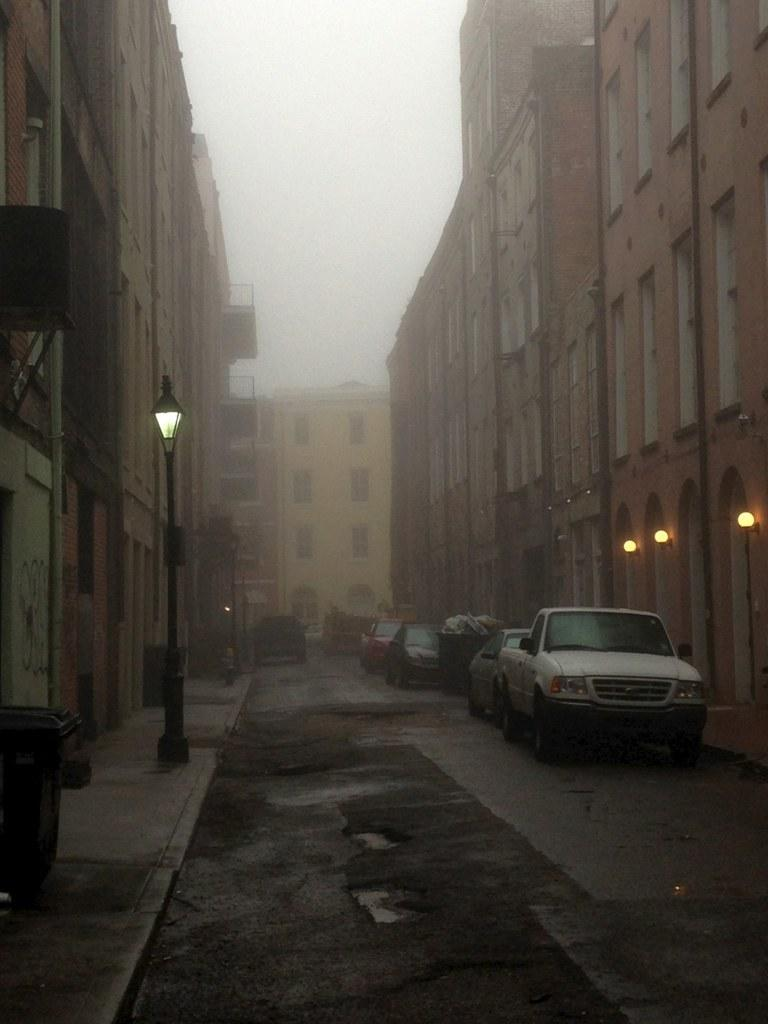What type of structures can be seen in the image? There are buildings in the image. What else can be seen on the ground in the image? There are vehicles on the road in the image. What can be seen illuminating the scene in the image? There are lights visible in the image. What are the tall, vertical objects in the image? There are poles in the image. What is visible in the background of the image? The sky is visible in the background of the image. What does your dad say about the houses in the image? There is no mention of a dad or houses in the image; it features buildings, vehicles, lights, poles, and the sky. What month is it in the image? The image does not provide information about the month; it only shows the scene with buildings, vehicles, lights, poles, and the sky. 